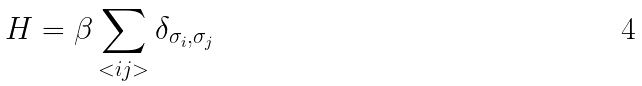Convert formula to latex. <formula><loc_0><loc_0><loc_500><loc_500>H = \beta \sum _ { < i j > } \delta _ { \sigma _ { i } , \sigma _ { j } }</formula> 